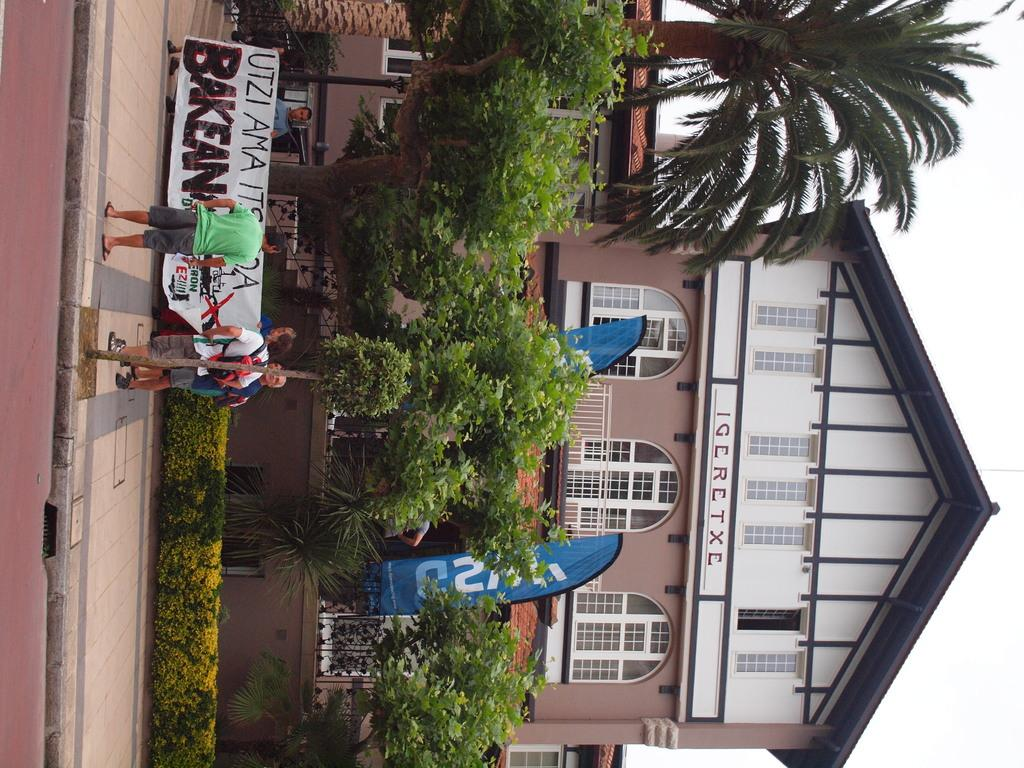What type of structures can be seen in the image? There are houses in the image. Are there any living beings present in the image? Yes, there are people in the image. What type of natural elements can be seen in the image? There are trees and plants in the image. What is the tall, vertical object in the image? There is a pole in the image. What type of signage is present in the image? There are posters with text in the image. What is visible at the bottom of the image? The ground is visible in the image. What is visible at the top of the image? The sky is visible in the image. Can you see any waves crashing on the shore in the image? There are no waves or shore visible in the image. What type of boot is being used by the people in the image? There are no boots visible in the image, and no information is provided about the footwear of the people. 